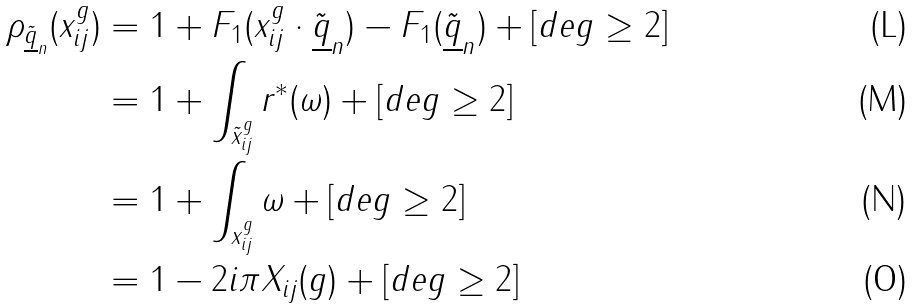Convert formula to latex. <formula><loc_0><loc_0><loc_500><loc_500>\rho _ { \tilde { \underline { q } } _ { n } } ( x _ { i j } ^ { g } ) & = 1 + F _ { 1 } ( x _ { i j } ^ { g } \cdot \tilde { \underline { q } } _ { n } ) - F _ { 1 } ( \tilde { \underline { q } } _ { n } ) + [ d e g \geq 2 ] \\ & = 1 + \int _ { \tilde { x } _ { i j } ^ { g } } r ^ { * } ( \omega ) + [ d e g \geq 2 ] \\ & = 1 + \int _ { x _ { i j } ^ { g } } \omega + [ d e g \geq 2 ] \\ & = 1 - 2 i \pi X _ { i j } ( g ) + [ d e g \geq 2 ]</formula> 